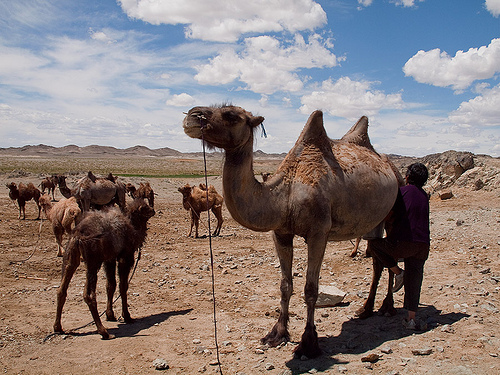<image>
Is there a camel on the camel? No. The camel is not positioned on the camel. They may be near each other, but the camel is not supported by or resting on top of the camel. 